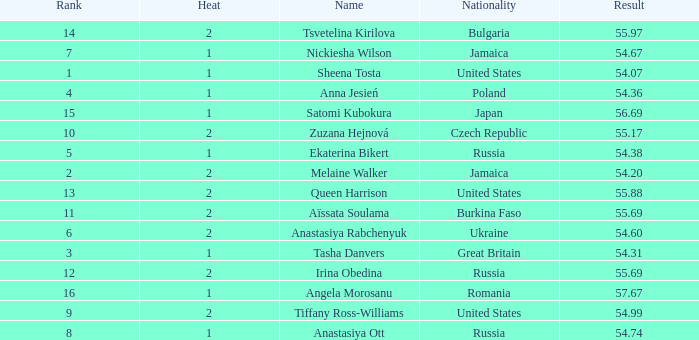Which Rank has a Name of tsvetelina kirilova, and a Result smaller than 55.97? None. 